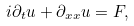<formula> <loc_0><loc_0><loc_500><loc_500>i \partial _ { t } u + \partial _ { x x } u = F ,</formula> 